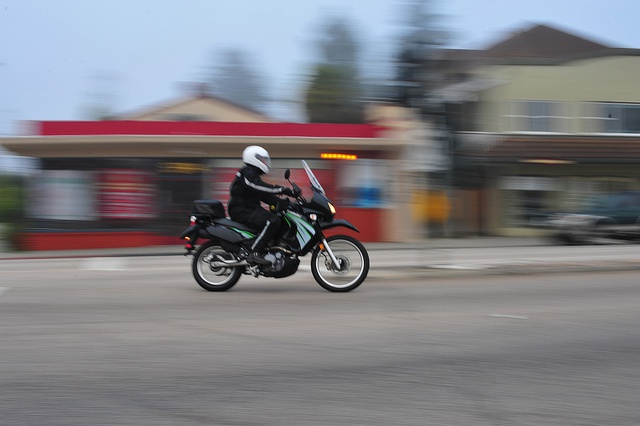Describe the objects in this image and their specific colors. I can see motorcycle in lightblue, black, gray, and darkgray tones, people in lightblue, black, gray, lightgray, and darkgray tones, and car in lightblue, gray, black, blue, and darkblue tones in this image. 